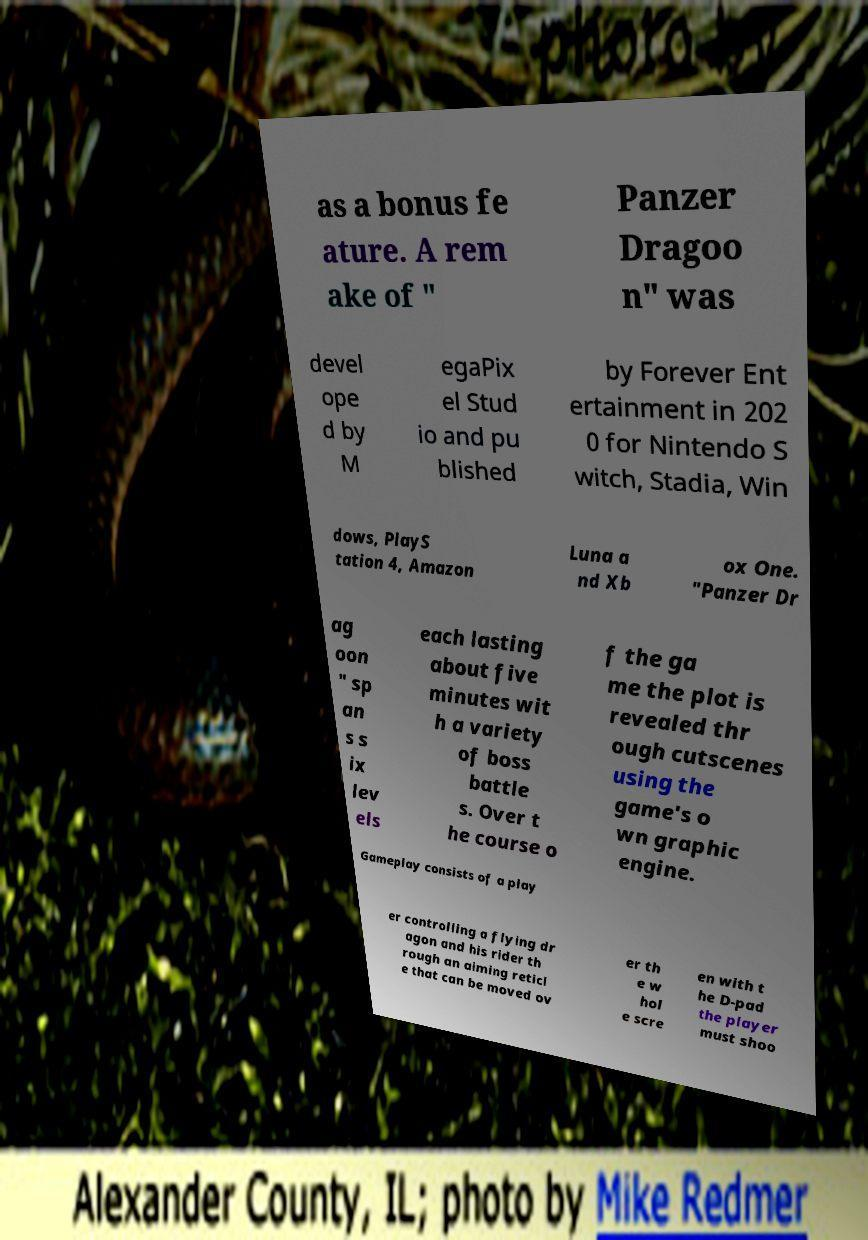Please read and relay the text visible in this image. What does it say? as a bonus fe ature. A rem ake of " Panzer Dragoo n" was devel ope d by M egaPix el Stud io and pu blished by Forever Ent ertainment in 202 0 for Nintendo S witch, Stadia, Win dows, PlayS tation 4, Amazon Luna a nd Xb ox One. "Panzer Dr ag oon " sp an s s ix lev els each lasting about five minutes wit h a variety of boss battle s. Over t he course o f the ga me the plot is revealed thr ough cutscenes using the game's o wn graphic engine. Gameplay consists of a play er controlling a flying dr agon and his rider th rough an aiming reticl e that can be moved ov er th e w hol e scre en with t he D-pad the player must shoo 